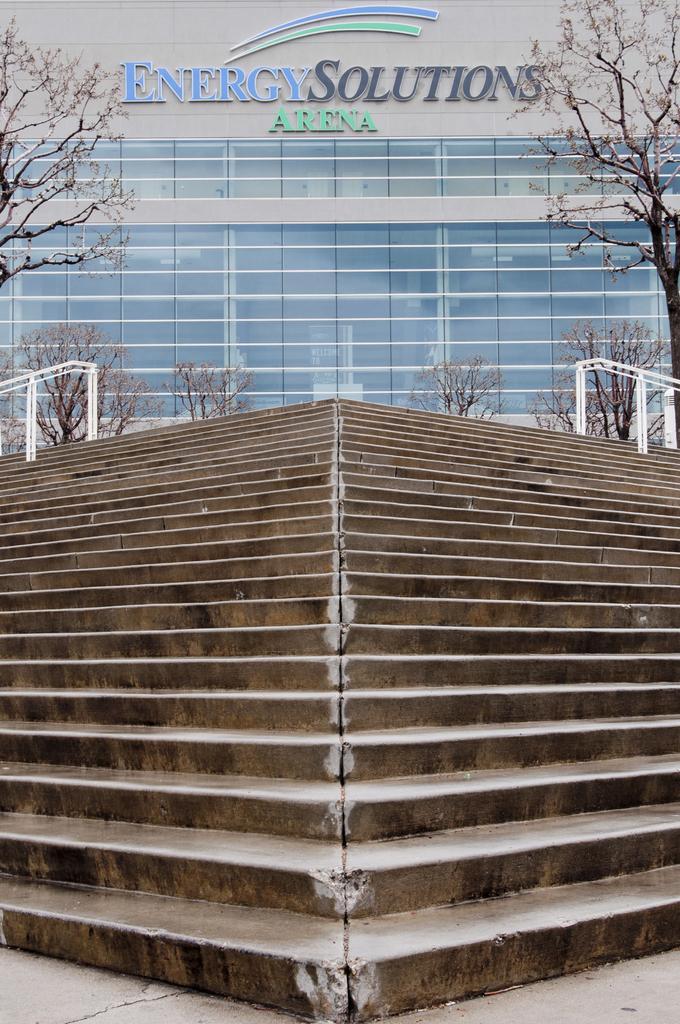Describe this image in one or two sentences. In this image we can see a building and text written on the building, there are some trees and stairs in front of the building. 